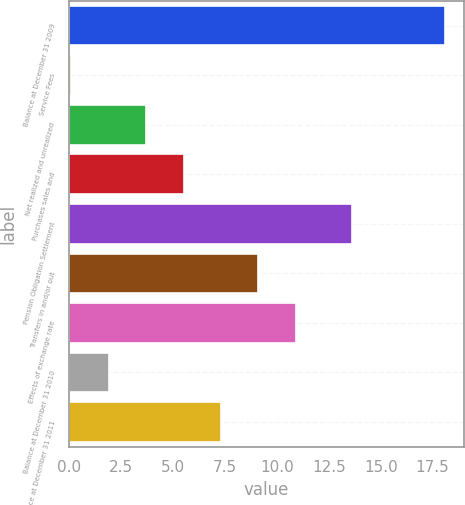Convert chart to OTSL. <chart><loc_0><loc_0><loc_500><loc_500><bar_chart><fcel>Balance at December 31 2009<fcel>Service Fees<fcel>Net realized and unrealized<fcel>Purchases sales and<fcel>Pension Obligation Settlement<fcel>Transfers in and/or out<fcel>Effects of exchange rate<fcel>Balance at December 31 2010<fcel>Balance at December 31 2011<nl><fcel>18.1<fcel>0.1<fcel>3.7<fcel>5.5<fcel>13.6<fcel>9.1<fcel>10.9<fcel>1.9<fcel>7.3<nl></chart> 